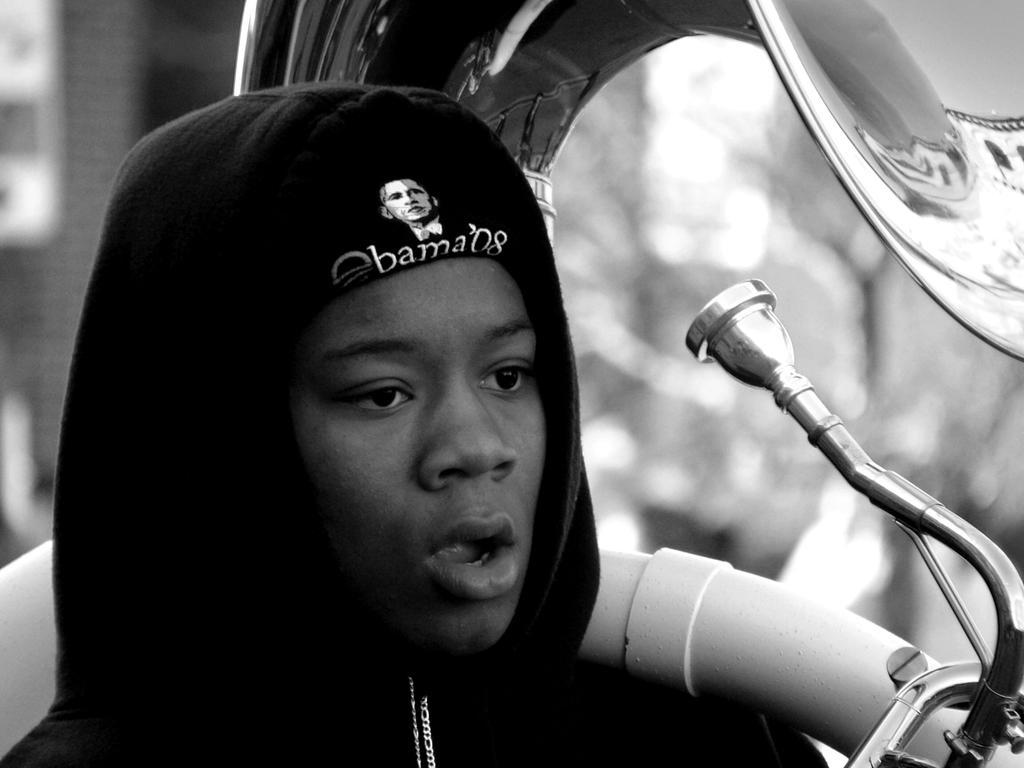In one or two sentences, can you explain what this image depicts? This image is taken outdoors. In this image the background is blurred. In the middle of the image there is a boy and he is holding a musical instrument in his hand. 